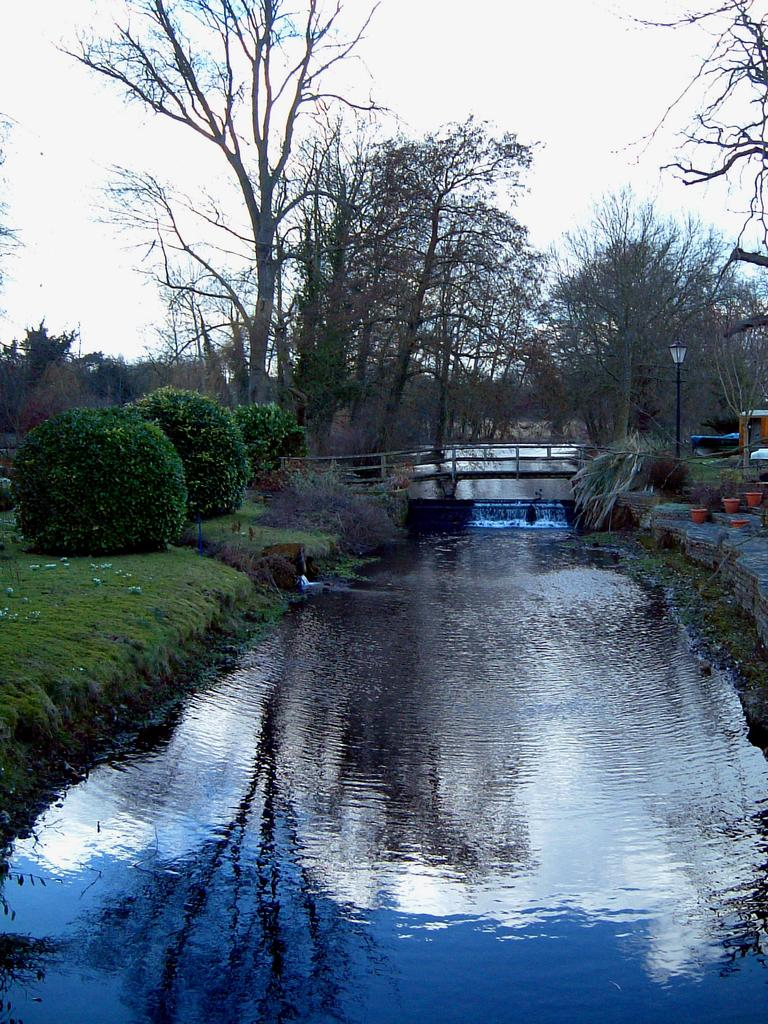What is located in the center of the image? There is water in the center of the image. What structure can be seen in the image? There is a bridge in the image. What type of vegetation is visible in the background of the image? Hedges and trees are visible in the background of the image. What additional features can be seen in the background of the image? Lights, flower pots, and stairs are present in the background of the image. What is visible at the top of the image? The sky is visible at the top of the image. How many trucks are parked near the water in the image? There are no trucks present in the image. Can you tell me how many houses are visible in the background of the image? There are no houses visible in the image; only a bridge, water, hedges, trees, lights, flower pots, stairs, and the sky are present. 